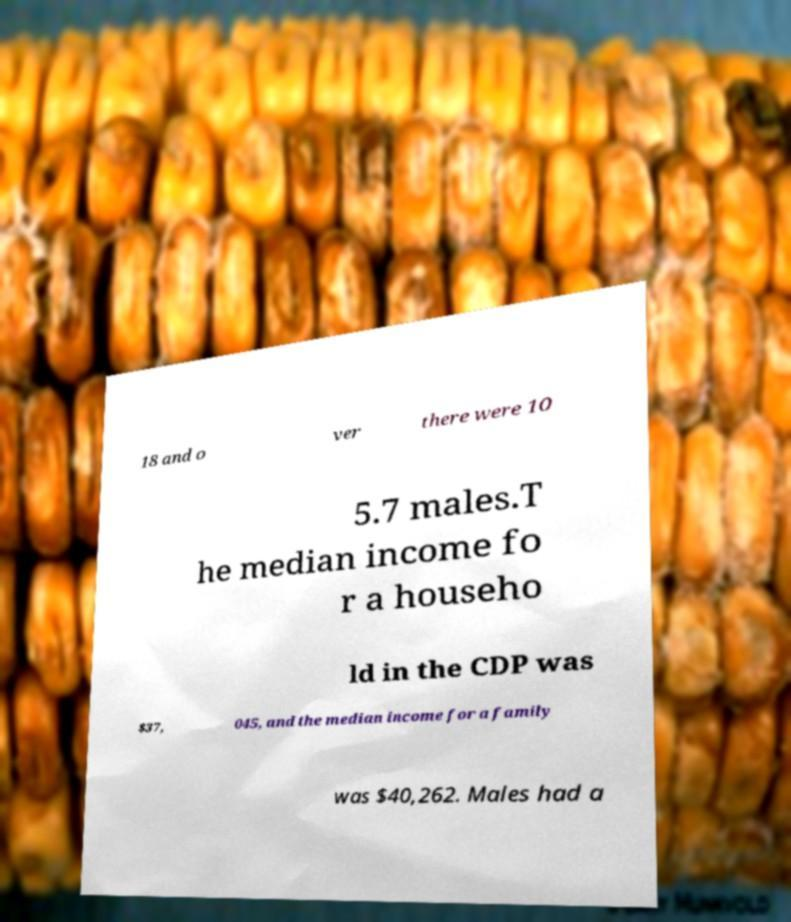For documentation purposes, I need the text within this image transcribed. Could you provide that? 18 and o ver there were 10 5.7 males.T he median income fo r a househo ld in the CDP was $37, 045, and the median income for a family was $40,262. Males had a 